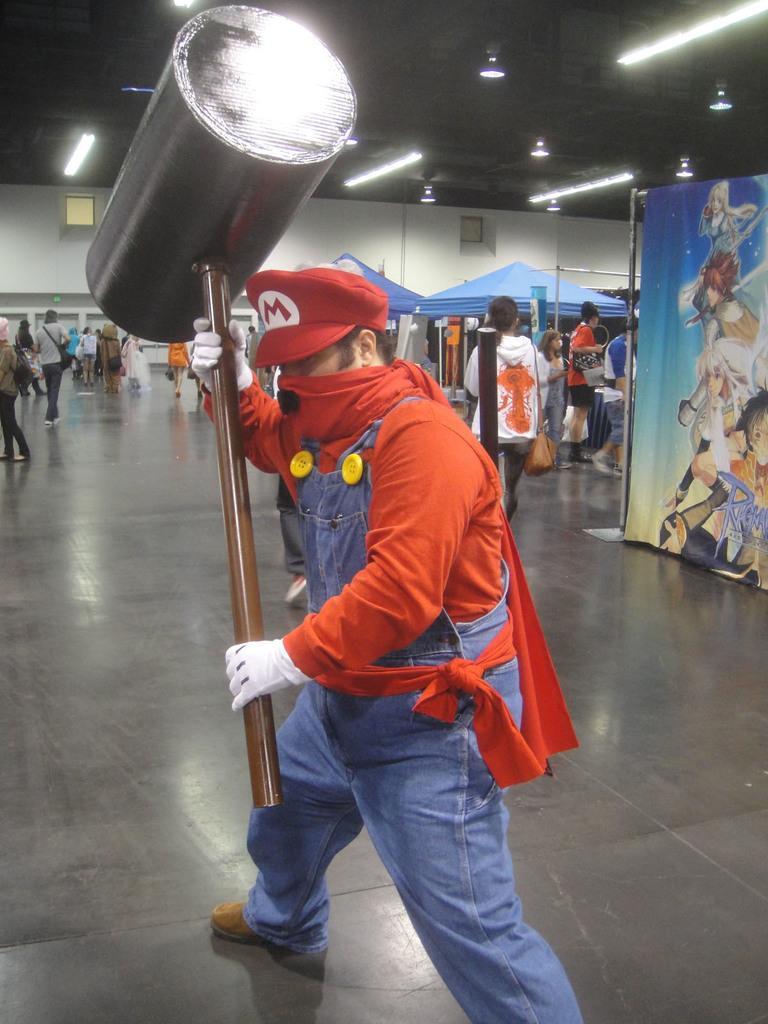Describe this image in one or two sentences. In this picture there is a person holding a giant hammer. He is wearing an orange t shirt and blue jeans. Towards the right, there is a banner with pictures. In the background there are people. On the top, there is a ceiling with lights. 